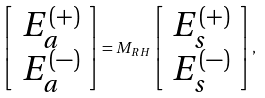<formula> <loc_0><loc_0><loc_500><loc_500>\left [ \begin{array} { c } E _ { a } ^ { ( + ) } \\ E _ { a } ^ { ( - ) } \end{array} \right ] = M _ { R H } \left [ \begin{array} { c } E _ { s } ^ { ( + ) } \\ E _ { s } ^ { ( - ) } \end{array} \right ] ,</formula> 